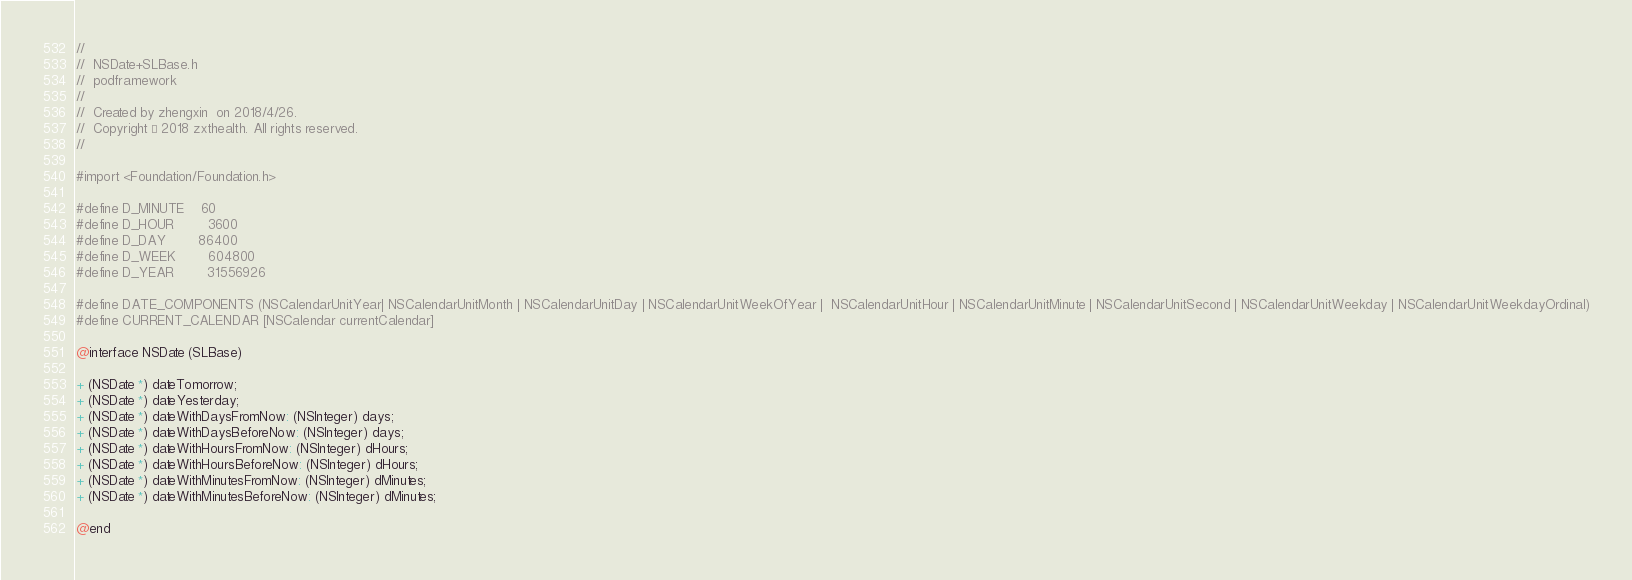<code> <loc_0><loc_0><loc_500><loc_500><_C_>//
//  NSDate+SLBase.h
//  podframework
//
//  Created by zhengxin  on 2018/4/26.
//  Copyright © 2018 zxthealth. All rights reserved.
//

#import <Foundation/Foundation.h>

#define D_MINUTE    60
#define D_HOUR        3600
#define D_DAY        86400
#define D_WEEK        604800
#define D_YEAR        31556926

#define DATE_COMPONENTS (NSCalendarUnitYear| NSCalendarUnitMonth | NSCalendarUnitDay | NSCalendarUnitWeekOfYear |  NSCalendarUnitHour | NSCalendarUnitMinute | NSCalendarUnitSecond | NSCalendarUnitWeekday | NSCalendarUnitWeekdayOrdinal)
#define CURRENT_CALENDAR [NSCalendar currentCalendar]

@interface NSDate (SLBase)

+ (NSDate *) dateTomorrow;
+ (NSDate *) dateYesterday;
+ (NSDate *) dateWithDaysFromNow: (NSInteger) days;
+ (NSDate *) dateWithDaysBeforeNow: (NSInteger) days;
+ (NSDate *) dateWithHoursFromNow: (NSInteger) dHours;
+ (NSDate *) dateWithHoursBeforeNow: (NSInteger) dHours;
+ (NSDate *) dateWithMinutesFromNow: (NSInteger) dMinutes;
+ (NSDate *) dateWithMinutesBeforeNow: (NSInteger) dMinutes;

@end
</code> 